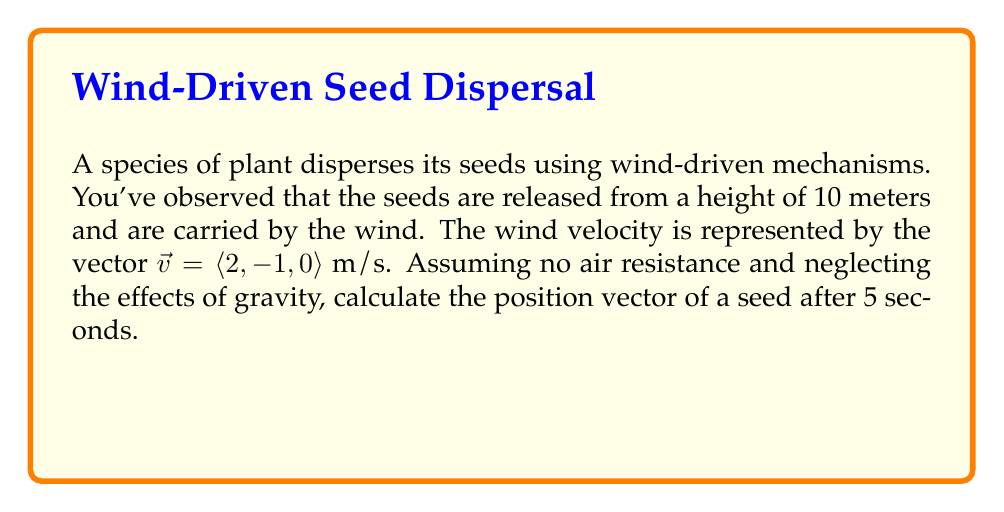Solve this math problem. Let's approach this step-by-step:

1) The initial position of the seed is at a height of 10 meters, so the initial position vector is:
   $\vec{r_0} = \langle 0, 0, 10 \rangle$

2) The velocity vector is given as:
   $\vec{v} = \langle 2, -1, 0 \rangle$ m/s

3) In the absence of air resistance and gravity, the seed will move with constant velocity. We can use the equation:
   $\vec{r} = \vec{r_0} + \vec{v}t$

   Where $\vec{r}$ is the final position vector, $\vec{r_0}$ is the initial position vector, $\vec{v}$ is the velocity vector, and $t$ is the time.

4) Substituting our known values:
   $\vec{r} = \langle 0, 0, 10 \rangle + \langle 2, -1, 0 \rangle \cdot 5$

5) Simplifying:
   $\vec{r} = \langle 0, 0, 10 \rangle + \langle 10, -5, 0 \rangle$

6) Adding the vectors:
   $\vec{r} = \langle 10, -5, 10 \rangle$

Therefore, after 5 seconds, the position vector of the seed will be $\langle 10, -5, 10 \rangle$ meters.
Answer: $\langle 10, -5, 10 \rangle$ m 